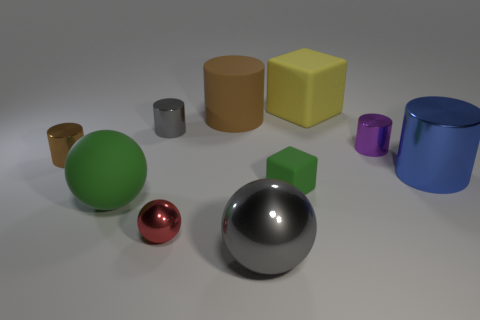Is the shape of the big blue metallic thing the same as the small gray shiny object?
Give a very brief answer. Yes. What number of matte objects are either big cyan cubes or cubes?
Keep it short and to the point. 2. Is there a rubber ball of the same size as the gray metal cylinder?
Your answer should be compact. No. What shape is the big object that is the same color as the tiny rubber block?
Provide a succinct answer. Sphere. What number of yellow matte cubes are the same size as the purple object?
Keep it short and to the point. 0. Do the rubber block that is on the right side of the tiny green block and the gray metallic object in front of the blue object have the same size?
Make the answer very short. Yes. How many things are small gray shiny objects or spheres behind the tiny metal ball?
Your answer should be very brief. 2. What is the color of the large metal cylinder?
Your response must be concise. Blue. The big ball to the left of the gray metal object on the right side of the gray thing behind the red thing is made of what material?
Offer a terse response. Rubber. The gray thing that is made of the same material as the gray cylinder is what size?
Your answer should be very brief. Large. 